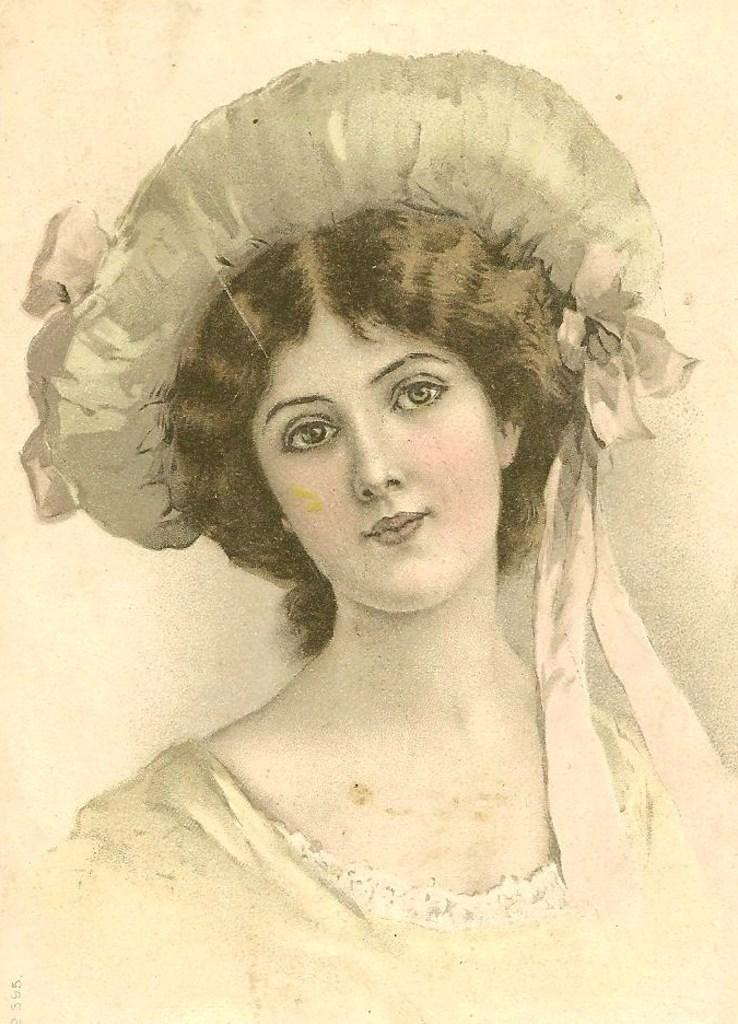What is the main subject of the image? There is a depiction ofiction of a woman in the image. What is the woman wearing on her head? The woman is wearing a hat. How many bees can be seen flying around the woman in the image? There are no bees visible in the image. What type of fold can be seen in the woman's clothing in the image? There is no fold visible in the woman's clothing in the image. 